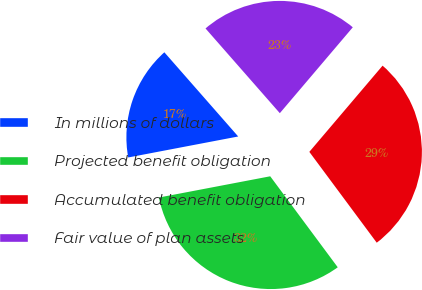Convert chart. <chart><loc_0><loc_0><loc_500><loc_500><pie_chart><fcel>In millions of dollars<fcel>Projected benefit obligation<fcel>Accumulated benefit obligation<fcel>Fair value of plan assets<nl><fcel>16.54%<fcel>32.16%<fcel>28.63%<fcel>22.67%<nl></chart> 